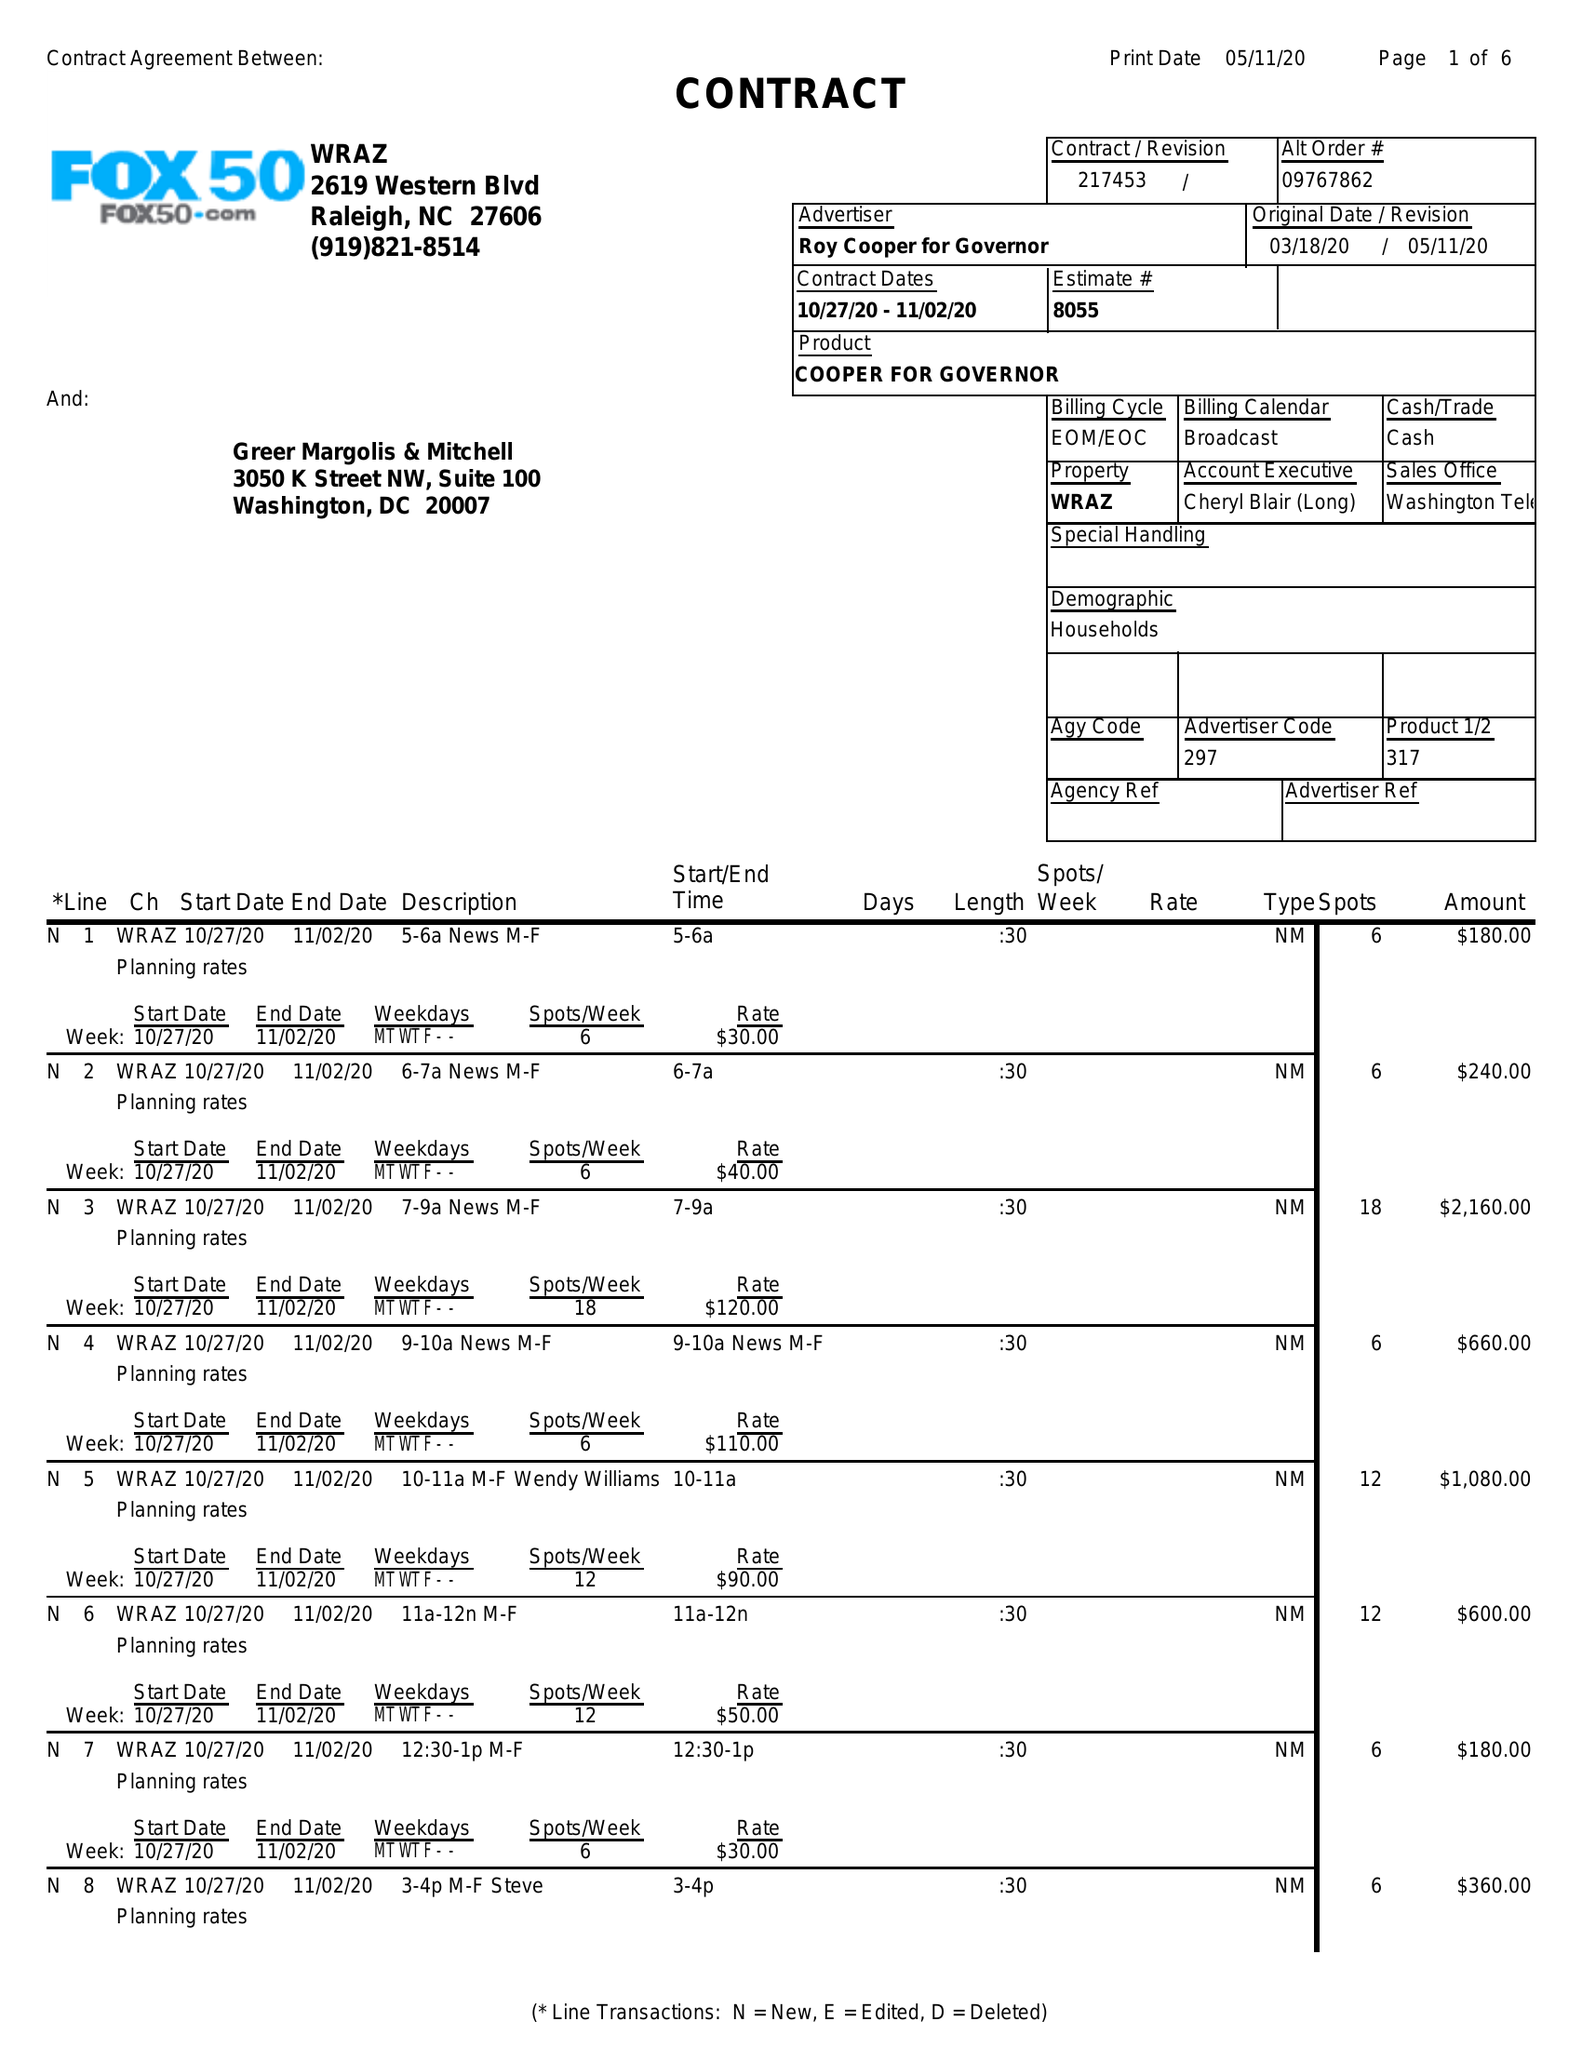What is the value for the flight_from?
Answer the question using a single word or phrase. 10/27/20 